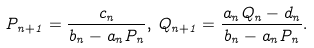<formula> <loc_0><loc_0><loc_500><loc_500>P _ { n + 1 } = \frac { c _ { n } } { b _ { n } - a _ { n } P _ { n } } , \, Q _ { n + 1 } = \frac { a _ { n } Q _ { n } - d _ { n } } { b _ { n } - a _ { n } P _ { n } } .</formula> 